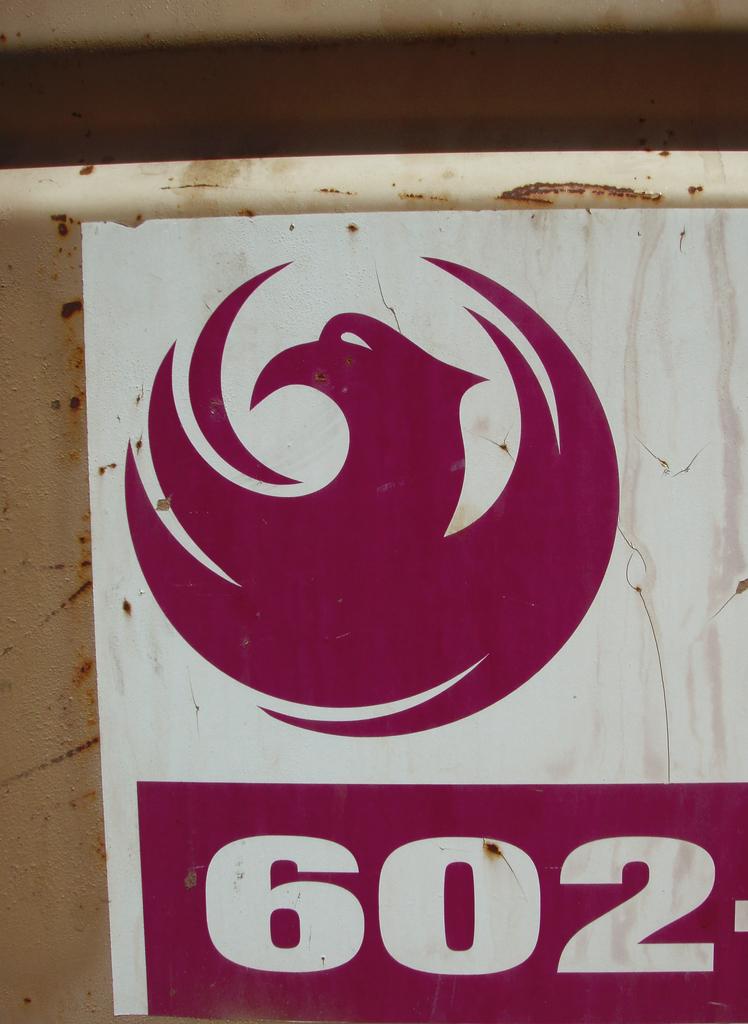What number is on this poster?
Offer a very short reply. 602. 